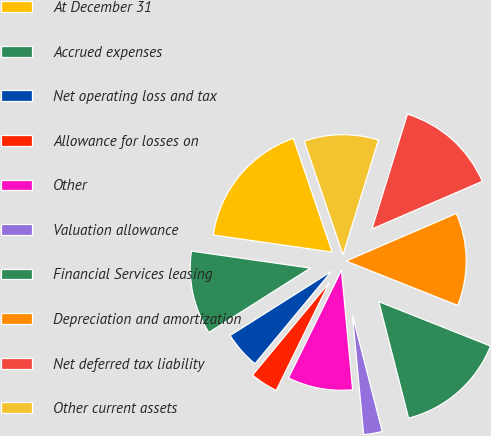Convert chart. <chart><loc_0><loc_0><loc_500><loc_500><pie_chart><fcel>At December 31<fcel>Accrued expenses<fcel>Net operating loss and tax<fcel>Allowance for losses on<fcel>Other<fcel>Valuation allowance<fcel>Financial Services leasing<fcel>Depreciation and amortization<fcel>Net deferred tax liability<fcel>Other current assets<nl><fcel>17.5%<fcel>11.25%<fcel>5.0%<fcel>3.75%<fcel>8.75%<fcel>2.5%<fcel>15.0%<fcel>12.5%<fcel>13.75%<fcel>10.0%<nl></chart> 